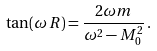<formula> <loc_0><loc_0><loc_500><loc_500>\tan ( \omega \, R ) = \frac { 2 \omega m } { \omega ^ { 2 } - M _ { 0 } ^ { 2 } } \, { . }</formula> 